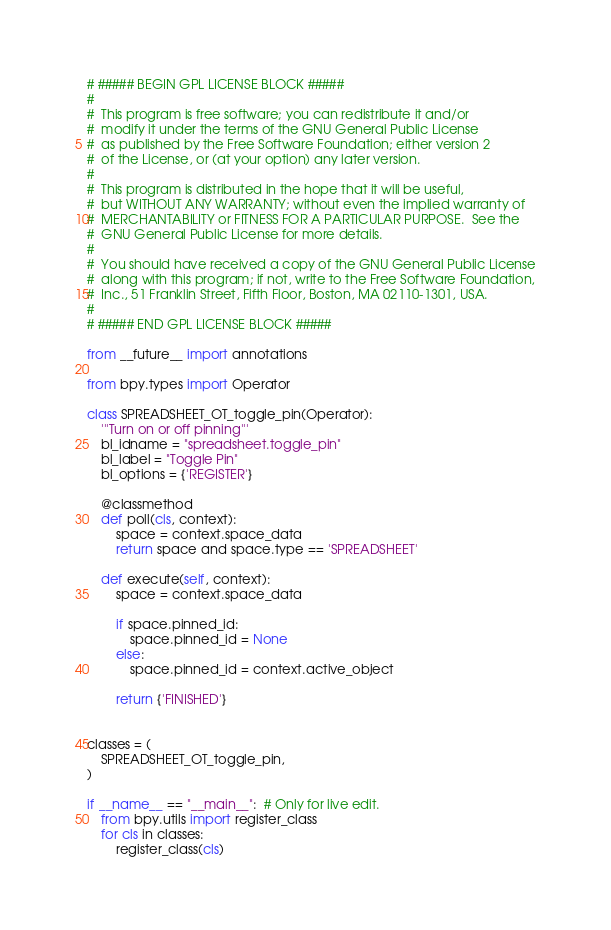<code> <loc_0><loc_0><loc_500><loc_500><_Python_># ##### BEGIN GPL LICENSE BLOCK #####
#
#  This program is free software; you can redistribute it and/or
#  modify it under the terms of the GNU General Public License
#  as published by the Free Software Foundation; either version 2
#  of the License, or (at your option) any later version.
#
#  This program is distributed in the hope that it will be useful,
#  but WITHOUT ANY WARRANTY; without even the implied warranty of
#  MERCHANTABILITY or FITNESS FOR A PARTICULAR PURPOSE.  See the
#  GNU General Public License for more details.
#
#  You should have received a copy of the GNU General Public License
#  along with this program; if not, write to the Free Software Foundation,
#  Inc., 51 Franklin Street, Fifth Floor, Boston, MA 02110-1301, USA.
#
# ##### END GPL LICENSE BLOCK #####

from __future__ import annotations

from bpy.types import Operator

class SPREADSHEET_OT_toggle_pin(Operator):
    '''Turn on or off pinning'''
    bl_idname = "spreadsheet.toggle_pin"
    bl_label = "Toggle Pin"
    bl_options = {'REGISTER'}

    @classmethod
    def poll(cls, context):
        space = context.space_data
        return space and space.type == 'SPREADSHEET'

    def execute(self, context):
        space = context.space_data

        if space.pinned_id:
            space.pinned_id = None
        else:
            space.pinned_id = context.active_object

        return {'FINISHED'}


classes = (
    SPREADSHEET_OT_toggle_pin,
)

if __name__ == "__main__":  # Only for live edit.
    from bpy.utils import register_class
    for cls in classes:
        register_class(cls)
</code> 